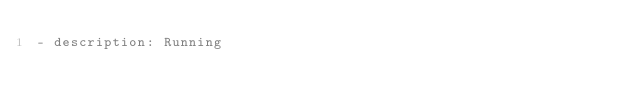<code> <loc_0><loc_0><loc_500><loc_500><_YAML_>- description: Running
</code> 